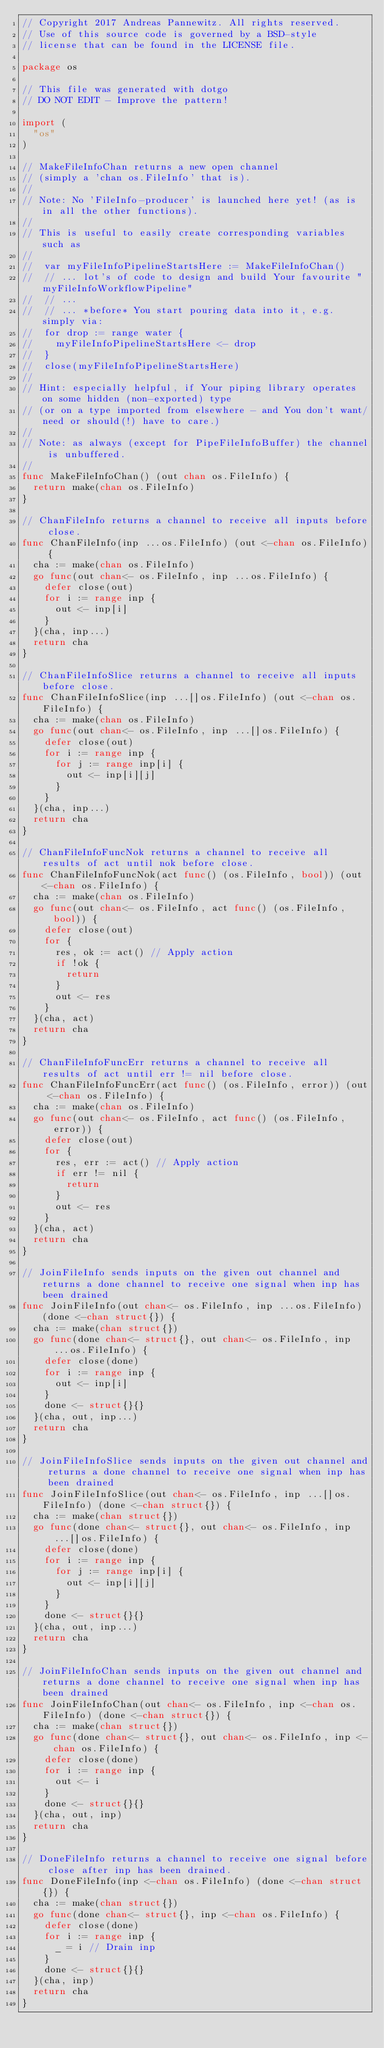Convert code to text. <code><loc_0><loc_0><loc_500><loc_500><_Go_>// Copyright 2017 Andreas Pannewitz. All rights reserved.
// Use of this source code is governed by a BSD-style
// license that can be found in the LICENSE file.

package os

// This file was generated with dotgo
// DO NOT EDIT - Improve the pattern!

import (
	"os"
)

// MakeFileInfoChan returns a new open channel
// (simply a 'chan os.FileInfo' that is).
//
// Note: No 'FileInfo-producer' is launched here yet! (as is in all the other functions).
//
// This is useful to easily create corresponding variables such as
//
//	var myFileInfoPipelineStartsHere := MakeFileInfoChan()
//	// ... lot's of code to design and build Your favourite "myFileInfoWorkflowPipeline"
//	// ...
//	// ... *before* You start pouring data into it, e.g. simply via:
//	for drop := range water {
//		myFileInfoPipelineStartsHere <- drop
//	}
//	close(myFileInfoPipelineStartsHere)
//
// Hint: especially helpful, if Your piping library operates on some hidden (non-exported) type
// (or on a type imported from elsewhere - and You don't want/need or should(!) have to care.)
//
// Note: as always (except for PipeFileInfoBuffer) the channel is unbuffered.
//
func MakeFileInfoChan() (out chan os.FileInfo) {
	return make(chan os.FileInfo)
}

// ChanFileInfo returns a channel to receive all inputs before close.
func ChanFileInfo(inp ...os.FileInfo) (out <-chan os.FileInfo) {
	cha := make(chan os.FileInfo)
	go func(out chan<- os.FileInfo, inp ...os.FileInfo) {
		defer close(out)
		for i := range inp {
			out <- inp[i]
		}
	}(cha, inp...)
	return cha
}

// ChanFileInfoSlice returns a channel to receive all inputs before close.
func ChanFileInfoSlice(inp ...[]os.FileInfo) (out <-chan os.FileInfo) {
	cha := make(chan os.FileInfo)
	go func(out chan<- os.FileInfo, inp ...[]os.FileInfo) {
		defer close(out)
		for i := range inp {
			for j := range inp[i] {
				out <- inp[i][j]
			}
		}
	}(cha, inp...)
	return cha
}

// ChanFileInfoFuncNok returns a channel to receive all results of act until nok before close.
func ChanFileInfoFuncNok(act func() (os.FileInfo, bool)) (out <-chan os.FileInfo) {
	cha := make(chan os.FileInfo)
	go func(out chan<- os.FileInfo, act func() (os.FileInfo, bool)) {
		defer close(out)
		for {
			res, ok := act() // Apply action
			if !ok {
				return
			}
			out <- res
		}
	}(cha, act)
	return cha
}

// ChanFileInfoFuncErr returns a channel to receive all results of act until err != nil before close.
func ChanFileInfoFuncErr(act func() (os.FileInfo, error)) (out <-chan os.FileInfo) {
	cha := make(chan os.FileInfo)
	go func(out chan<- os.FileInfo, act func() (os.FileInfo, error)) {
		defer close(out)
		for {
			res, err := act() // Apply action
			if err != nil {
				return
			}
			out <- res
		}
	}(cha, act)
	return cha
}

// JoinFileInfo sends inputs on the given out channel and returns a done channel to receive one signal when inp has been drained
func JoinFileInfo(out chan<- os.FileInfo, inp ...os.FileInfo) (done <-chan struct{}) {
	cha := make(chan struct{})
	go func(done chan<- struct{}, out chan<- os.FileInfo, inp ...os.FileInfo) {
		defer close(done)
		for i := range inp {
			out <- inp[i]
		}
		done <- struct{}{}
	}(cha, out, inp...)
	return cha
}

// JoinFileInfoSlice sends inputs on the given out channel and returns a done channel to receive one signal when inp has been drained
func JoinFileInfoSlice(out chan<- os.FileInfo, inp ...[]os.FileInfo) (done <-chan struct{}) {
	cha := make(chan struct{})
	go func(done chan<- struct{}, out chan<- os.FileInfo, inp ...[]os.FileInfo) {
		defer close(done)
		for i := range inp {
			for j := range inp[i] {
				out <- inp[i][j]
			}
		}
		done <- struct{}{}
	}(cha, out, inp...)
	return cha
}

// JoinFileInfoChan sends inputs on the given out channel and returns a done channel to receive one signal when inp has been drained
func JoinFileInfoChan(out chan<- os.FileInfo, inp <-chan os.FileInfo) (done <-chan struct{}) {
	cha := make(chan struct{})
	go func(done chan<- struct{}, out chan<- os.FileInfo, inp <-chan os.FileInfo) {
		defer close(done)
		for i := range inp {
			out <- i
		}
		done <- struct{}{}
	}(cha, out, inp)
	return cha
}

// DoneFileInfo returns a channel to receive one signal before close after inp has been drained.
func DoneFileInfo(inp <-chan os.FileInfo) (done <-chan struct{}) {
	cha := make(chan struct{})
	go func(done chan<- struct{}, inp <-chan os.FileInfo) {
		defer close(done)
		for i := range inp {
			_ = i // Drain inp
		}
		done <- struct{}{}
	}(cha, inp)
	return cha
}
</code> 